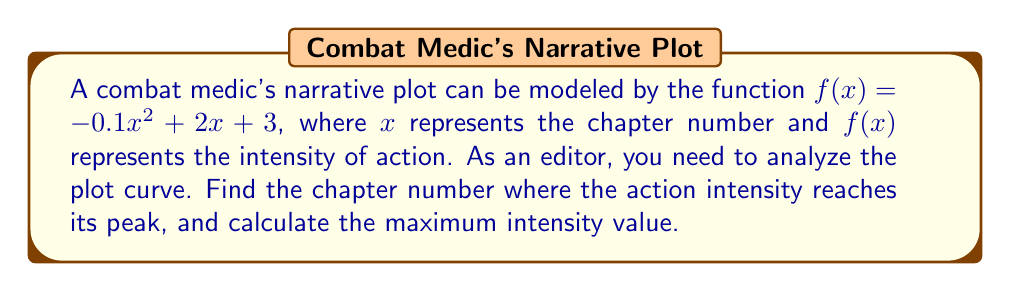Help me with this question. 1) The function $f(x) = -0.1x^2 + 2x + 3$ is a quadratic function, which forms a parabola.

2) For a quadratic function in the form $f(x) = ax^2 + bx + c$, the x-coordinate of the vertex (which represents the peak in this case) is given by $x = -\frac{b}{2a}$.

3) In this case, $a = -0.1$ and $b = 2$. So:

   $x = -\frac{2}{2(-0.1)} = -\frac{2}{-0.2} = 10$

4) This means the action intensity reaches its peak at chapter 10.

5) To find the maximum intensity value, we substitute $x = 10$ into the original function:

   $f(10) = -0.1(10)^2 + 2(10) + 3$
          $= -0.1(100) + 20 + 3$
          $= -10 + 20 + 3$
          $= 13$

6) Therefore, the maximum intensity value is 13.
Answer: Chapter 10; Maximum intensity 13 